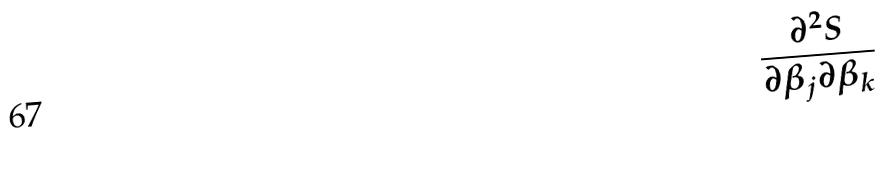<formula> <loc_0><loc_0><loc_500><loc_500>\frac { \partial ^ { 2 } S } { \partial \beta _ { j } \partial \beta _ { k } }</formula> 